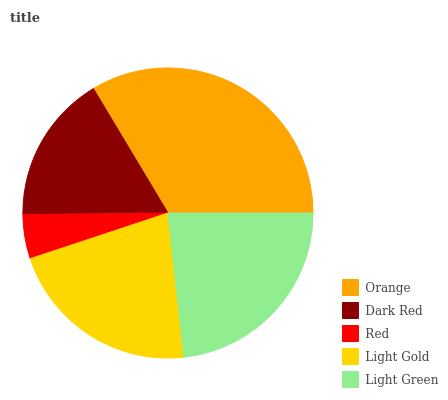Is Red the minimum?
Answer yes or no. Yes. Is Orange the maximum?
Answer yes or no. Yes. Is Dark Red the minimum?
Answer yes or no. No. Is Dark Red the maximum?
Answer yes or no. No. Is Orange greater than Dark Red?
Answer yes or no. Yes. Is Dark Red less than Orange?
Answer yes or no. Yes. Is Dark Red greater than Orange?
Answer yes or no. No. Is Orange less than Dark Red?
Answer yes or no. No. Is Light Gold the high median?
Answer yes or no. Yes. Is Light Gold the low median?
Answer yes or no. Yes. Is Red the high median?
Answer yes or no. No. Is Red the low median?
Answer yes or no. No. 